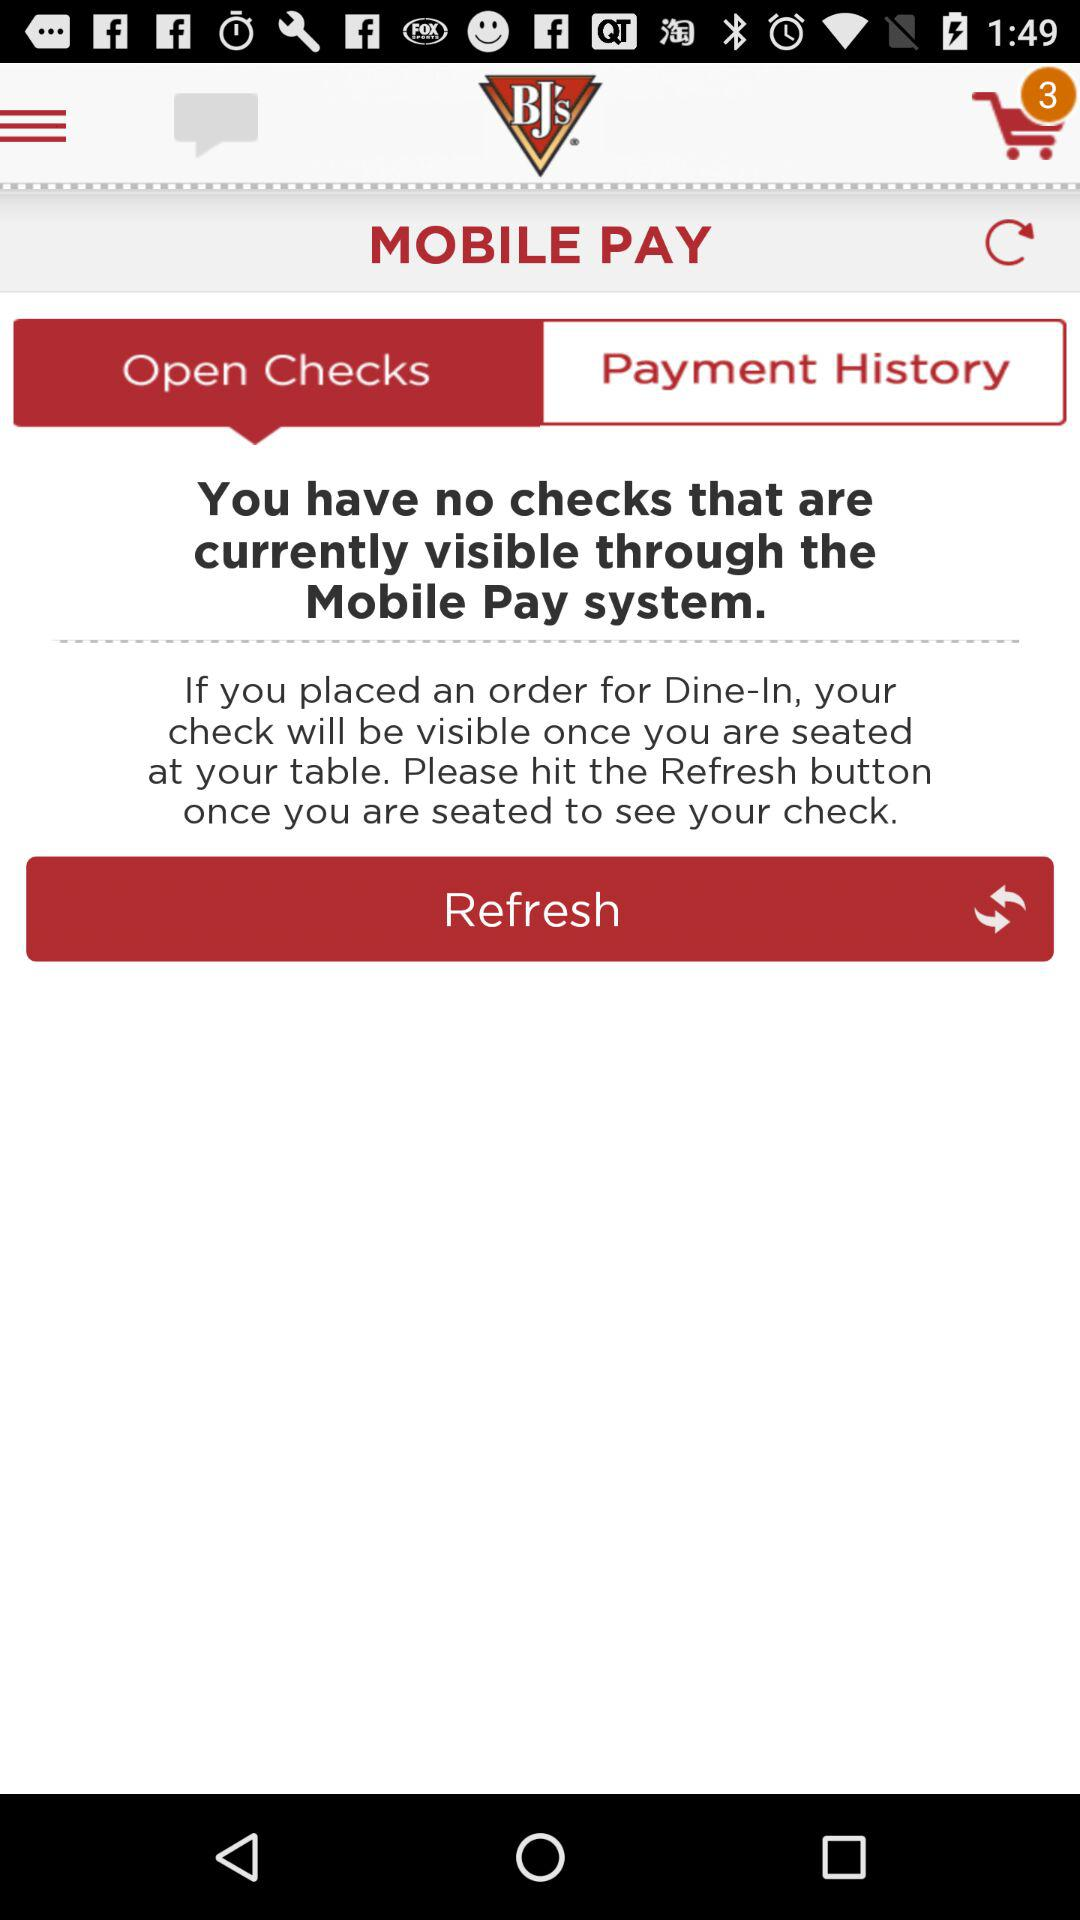What is the application name? The application name is "BJ’s Mobile App". 